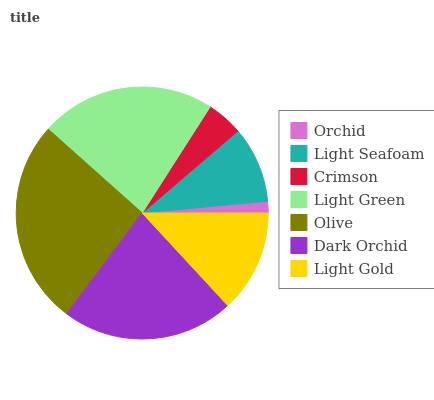Is Orchid the minimum?
Answer yes or no. Yes. Is Olive the maximum?
Answer yes or no. Yes. Is Light Seafoam the minimum?
Answer yes or no. No. Is Light Seafoam the maximum?
Answer yes or no. No. Is Light Seafoam greater than Orchid?
Answer yes or no. Yes. Is Orchid less than Light Seafoam?
Answer yes or no. Yes. Is Orchid greater than Light Seafoam?
Answer yes or no. No. Is Light Seafoam less than Orchid?
Answer yes or no. No. Is Light Gold the high median?
Answer yes or no. Yes. Is Light Gold the low median?
Answer yes or no. Yes. Is Dark Orchid the high median?
Answer yes or no. No. Is Dark Orchid the low median?
Answer yes or no. No. 